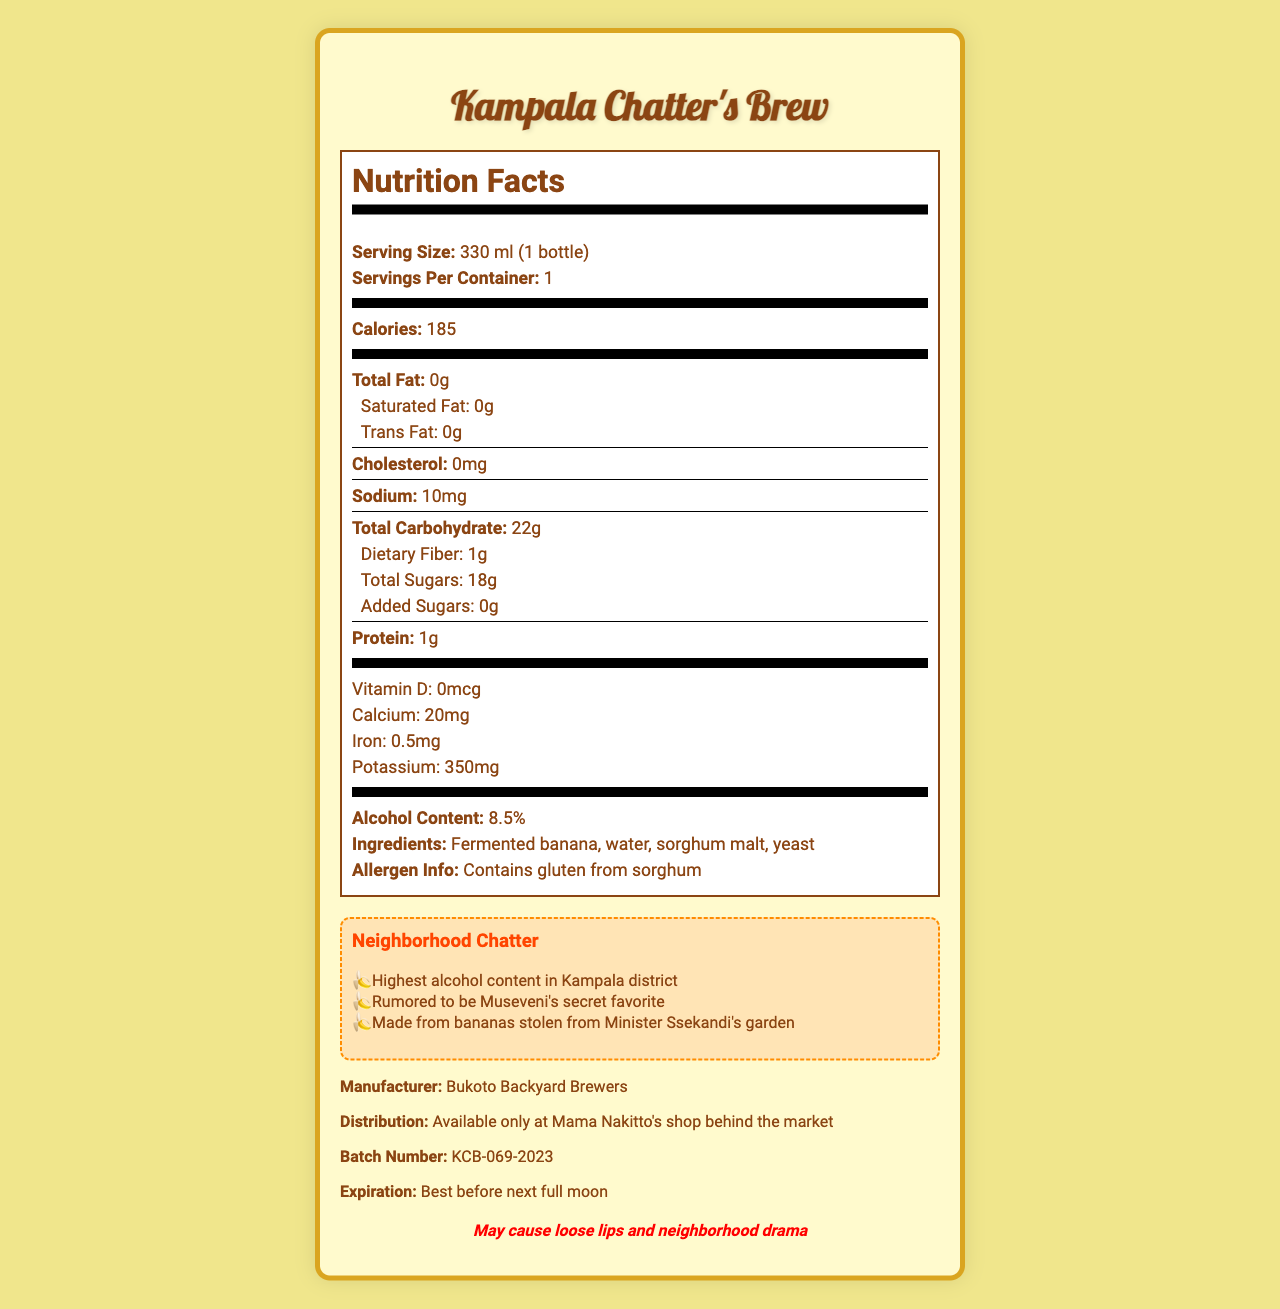what is the serving size of Kampala Chatter's Brew? The serving size is explicitly stated in the document as "330 ml (1 bottle)."
Answer: 330 ml (1 bottle) how many calories are in each bottle of Kampala Chatter's Brew? The document mentions that each serving, which is one bottle, contains 185 calories.
Answer: 185 calories what is the alcohol content of Kampala Chatter's Brew? The alcohol content is listed in the document as 8.5%.
Answer: 8.5% what is one potential allergen in Kampala Chatter's Brew? The allergen information in the document states that it contains gluten from sorghum.
Answer: Gluten from sorghum where is Kampala Chatter's Brew available for purchase? The document mentions that it is available only at Mama Nakitto's shop behind the market.
Answer: Mama Nakitto's shop behind the market which fact about Kampala Chatter's Brew is mentioned in the 'Neighborhood Chatter' section? A. It contains the lowest alcohol content in Kampala district B. It is made from mangoes C. It is rumored to be Museveni's secret favorite D. It is available in all supermarkets The 'Neighborhood Chatter' section includes gossip that it is rumored to be Museveni's secret favorite.
Answer: C what is the expiration date for Kampala Chatter's Brew? A. Best before end of the year B. Best before next rainy season C. Best before next full moon D. Best before next market day The document states that the expiration date is "Best before next full moon."
Answer: C is Kampala Chatter's Brew likely to be a low-fat beverage? The document indicates that the total fat content is 0g, suggesting it is a low-fat beverage.
Answer: Yes does Kampala Chatter's Brew contain any added sugars? The document specifies that the total added sugars are 0g.
Answer: No what is the warning associated with Kampala Chatter's Brew? The warning listed in the document states, "May cause loose lips and neighborhood drama."
Answer: May cause loose lips and neighborhood drama describe the main idea of the document. The document mainly describes the various nutritional and product details of a locally brewed banana beer called "Kampala Chatter's Brew," along with some local gossip and a humorous warning.
Answer: The document provides nutrition facts and other information about Kampala Chatter's Brew, a locally brewed banana beer. It includes details such as serving size, calories, alcohol content, ingredients, allergen information, gossip-worthy facts, manufacturer, and distribution information. There is also a humorous warning about its potential social effects. how much cholesterol is in one serving of Kampala Chatter's Brew? The document states that the cholesterol content is 0mg per serving.
Answer: 0mg how can you describe the nutrition label section of Kampala Chatter's Brew? The nutrition label section breaks down the nutritional components, including macro- and micronutrients, as well as additional information about alcohol and potential allergens.
Answer: It provides detailed information on nutrients, highlighting calories, total fat, cholesterol, sodium, carbohydrates, protein, vitamins, and minerals. It also specifies the alcohol content and allergen info. who is the manufacturer of Kampala Chatter's Brew? The document lists Bukoto Backyard Brewers as the manufacturer.
Answer: Bukoto Backyard Brewers which gossip fact is related to the ingredients of Kampala Chatter's Brew? The gossip section mentions that the beer is made from bananas stolen from Minister Ssekandi's garden.
Answer: Made from bananas stolen from Minister Ssekandi's garden who is rumored to be a fan of Kampala Chatter's Brew? According to the gossip section, Museveni is rumored to be a secret fan of the brew.
Answer: Museveni what is the batch number for Kampala Chatter's Brew? The batch number listed in the document is KCB-069-2023.
Answer: KCB-069-2023 can you determine the exact source of the bananas used in Kampala Chatter's Brew? The document contains a gossip-worthy statement about the bananas being stolen from Minister Ssekandi's garden, but this cannot be confirmed as a factual source.
Answer: Not enough information 